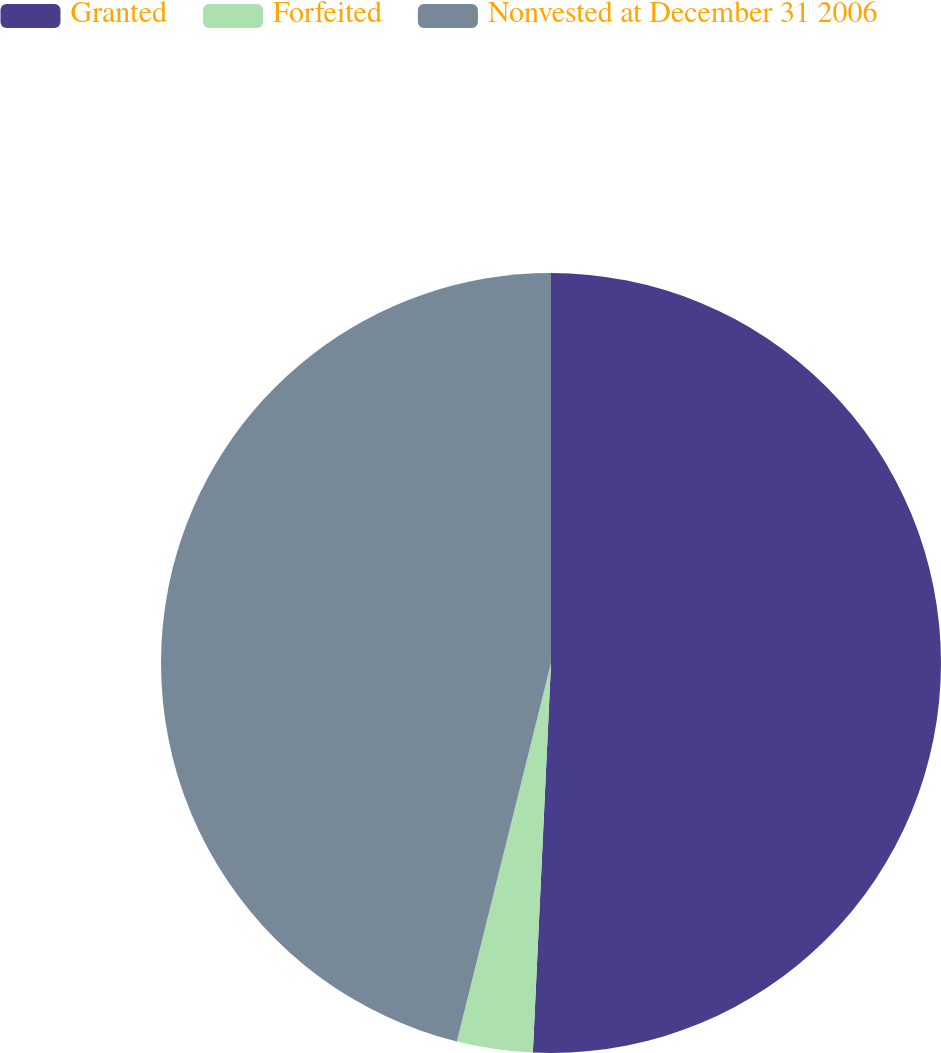Convert chart. <chart><loc_0><loc_0><loc_500><loc_500><pie_chart><fcel>Granted<fcel>Forfeited<fcel>Nonvested at December 31 2006<nl><fcel>50.74%<fcel>3.14%<fcel>46.12%<nl></chart> 